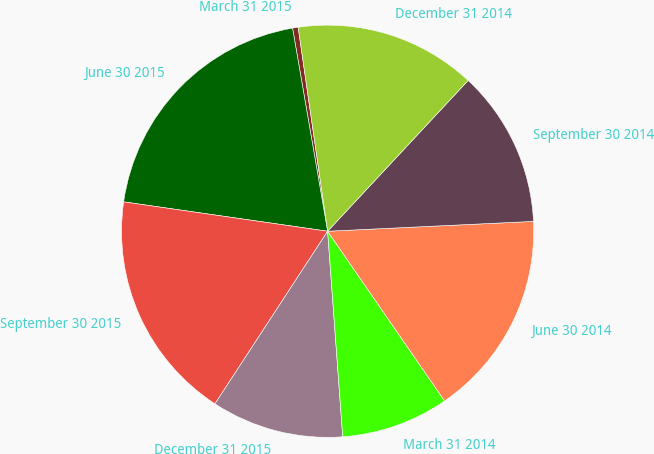<chart> <loc_0><loc_0><loc_500><loc_500><pie_chart><fcel>March 31 2015<fcel>June 30 2015<fcel>September 30 2015<fcel>December 31 2015<fcel>March 31 2014<fcel>June 30 2014<fcel>September 30 2014<fcel>December 31 2014<nl><fcel>0.44%<fcel>20.0%<fcel>18.07%<fcel>10.37%<fcel>8.44%<fcel>16.15%<fcel>12.3%<fcel>14.22%<nl></chart> 